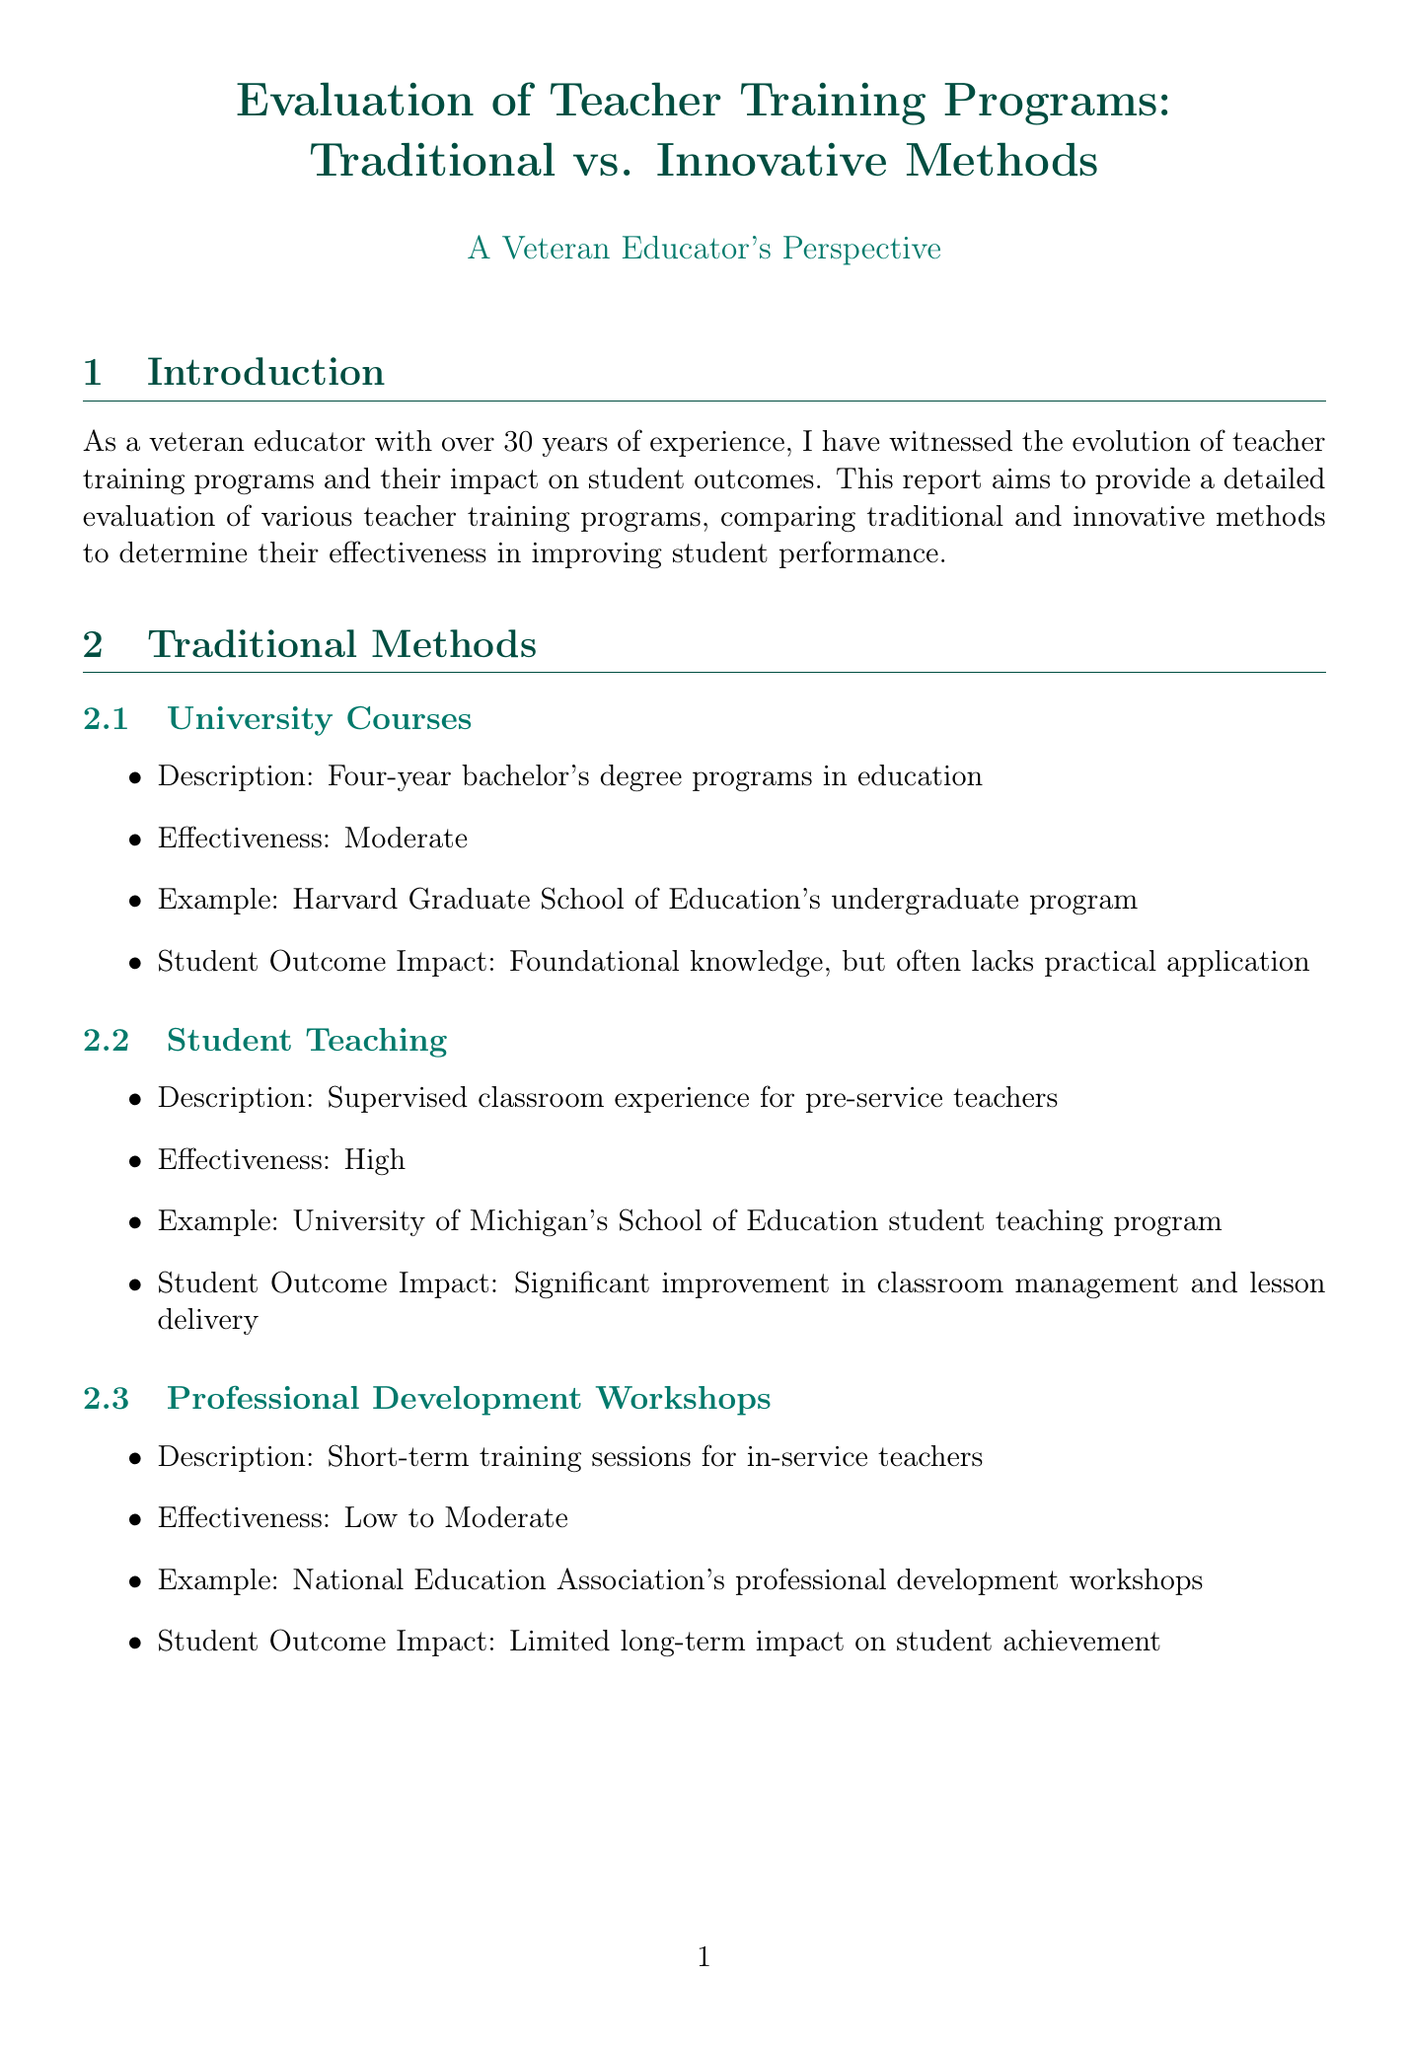What is the report title? The title of the report is presented at the beginning and summarizes the content focusing on teacher training programs.
Answer: Evaluation of Teacher Training Programs: Traditional vs. Innovative Methods What is the effectiveness rating for professional development workshops? The effectiveness rating for professional development workshops is explicitly stated in the document to highlight its impact on students.
Answer: Low to Moderate Which case study discusses Singapore's teacher training transformation? The document includes specific case studies, and this one is outlined to showcase successful reforms in the country.
Answer: Singapore's Teacher Training Transformation What is the effectiveness of virtual reality simulations? The document provides effectiveness ratings for various methods, including this innovative approach to teacher training.
Answer: Very High What are the metrics used in the comparative analysis? The document lists several effectiveness metrics used for comparison, which helps in evaluating the training programs.
Answer: Teacher retention rates, Student standardized test scores, Classroom observation ratings, Student engagement levels, Parent satisfaction surveys What do the key findings suggest about traditional methods? The key findings present conclusions drawn from the analysis of both traditional and innovative methods in the report.
Answer: Provide a strong foundation but lack adaptability What does the conclusion recommend? The conclusion summarizes insights and offers a recommendation based on the findings of the report, specifically advocating for a combined approach.
Answer: A balanced, adaptive approach that combines the best of both worlds Which innovative method is associated with improved teacher skills in specific areas? The document highlights various innovative methods, and this method is particularly noted for its targeted approach to skill enhancement.
Answer: Micro-Credentials 